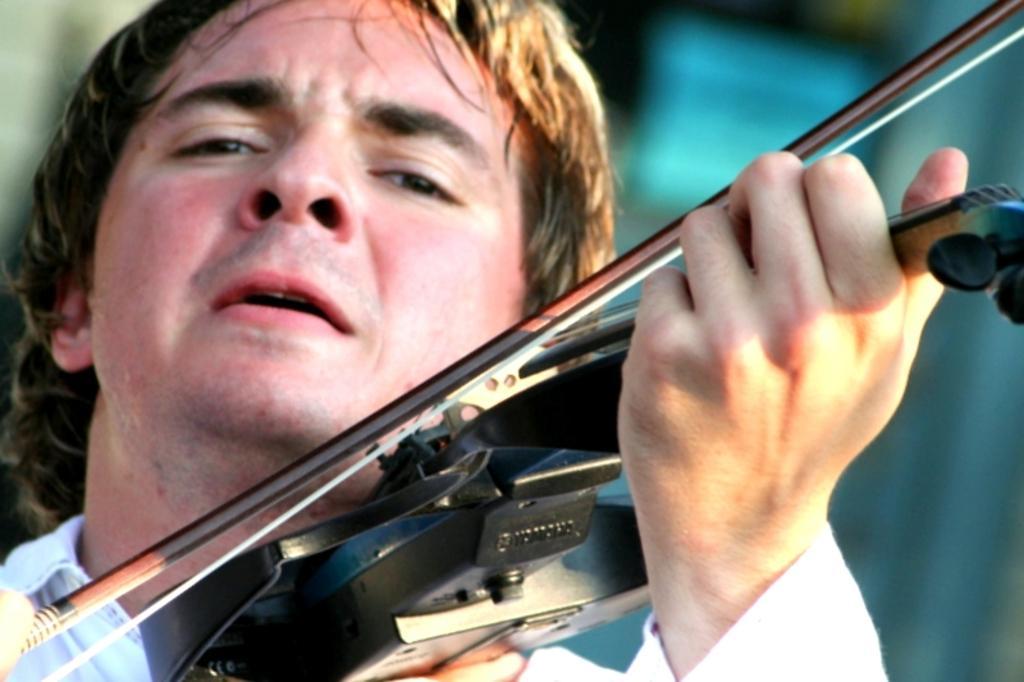Could you give a brief overview of what you see in this image? In this image there is a man who is playing the violin. 